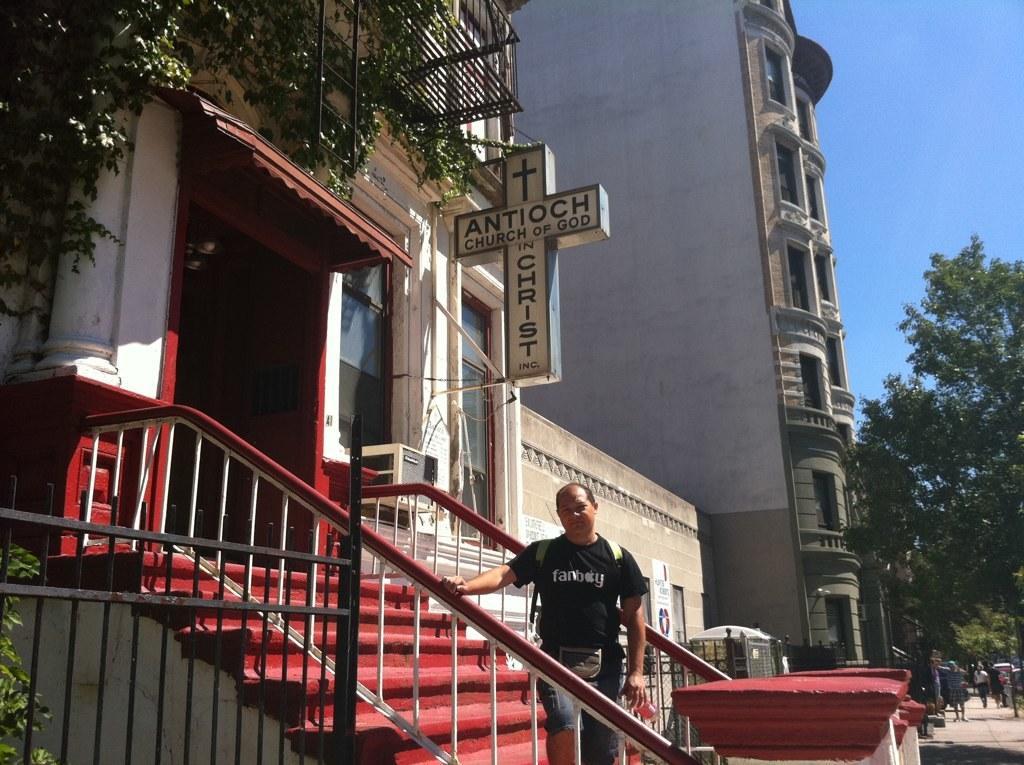How would you summarize this image in a sentence or two? There is a man standing and holding an object. We can see steps,fences,boards and buildings,left side of the image we can see tree. In the background we can see people,trees and sky in blue color. 